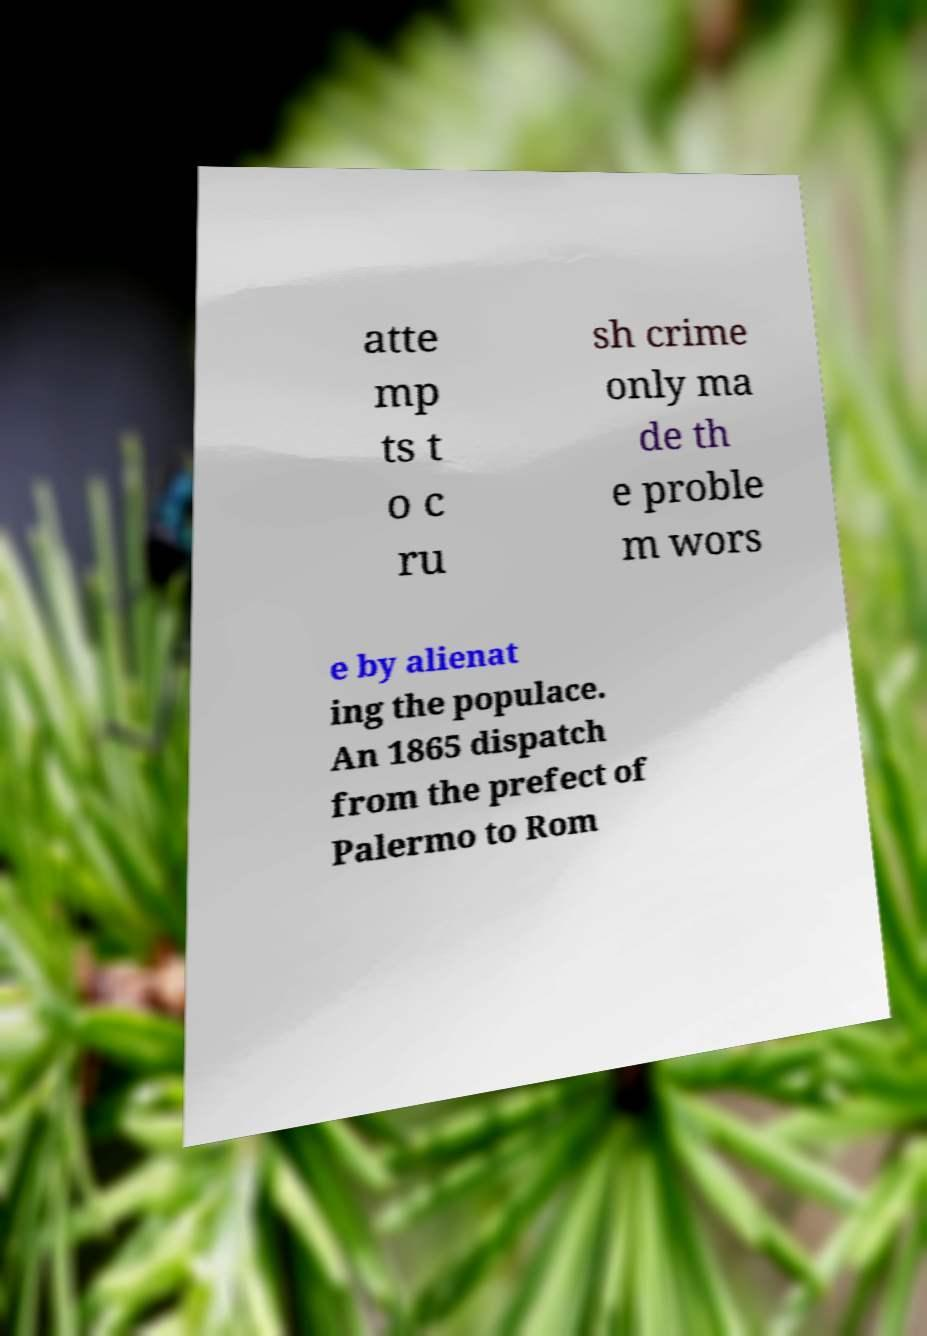There's text embedded in this image that I need extracted. Can you transcribe it verbatim? atte mp ts t o c ru sh crime only ma de th e proble m wors e by alienat ing the populace. An 1865 dispatch from the prefect of Palermo to Rom 